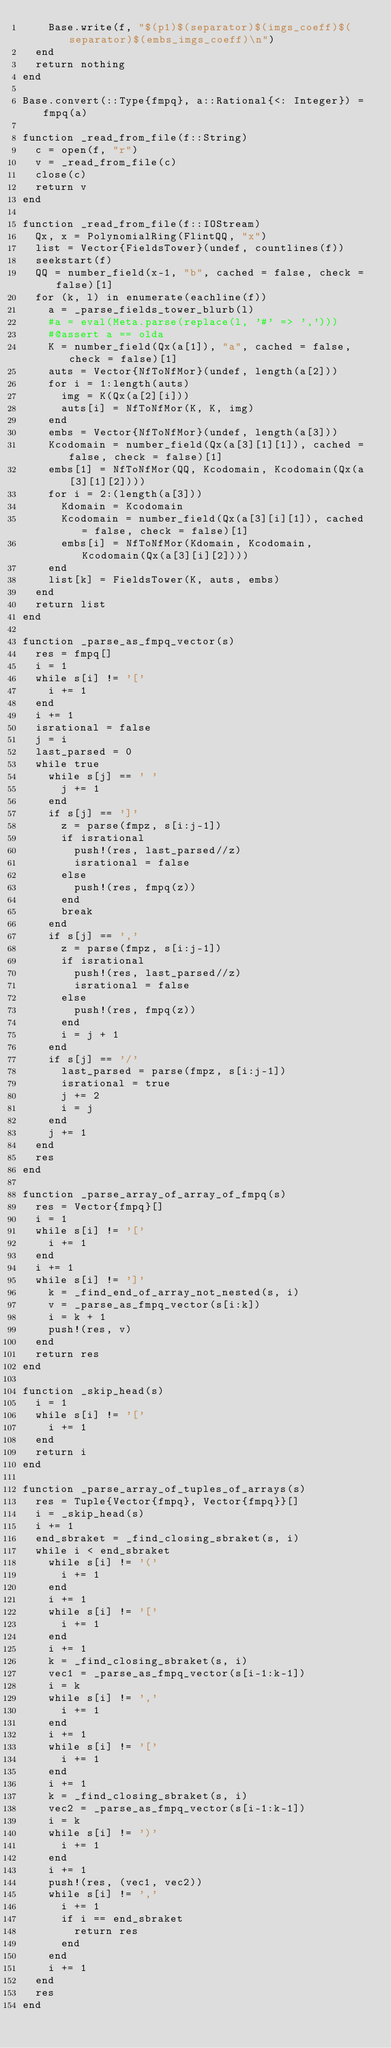Convert code to text. <code><loc_0><loc_0><loc_500><loc_500><_Julia_>    Base.write(f, "$(p1)$(separator)$(imgs_coeff)$(separator)$(embs_imgs_coeff)\n")
  end
  return nothing
end

Base.convert(::Type{fmpq}, a::Rational{<: Integer}) = fmpq(a)

function _read_from_file(f::String)
  c = open(f, "r")
  v = _read_from_file(c)
  close(c)
  return v
end

function _read_from_file(f::IOStream)
  Qx, x = PolynomialRing(FlintQQ, "x")
  list = Vector{FieldsTower}(undef, countlines(f))
  seekstart(f)
  QQ = number_field(x-1, "b", cached = false, check = false)[1]
  for (k, l) in enumerate(eachline(f))
    a = _parse_fields_tower_blurb(l)
    #a = eval(Meta.parse(replace(l, '#' => ',')))
    #@assert a == olda
    K = number_field(Qx(a[1]), "a", cached = false, check = false)[1]
    auts = Vector{NfToNfMor}(undef, length(a[2]))
    for i = 1:length(auts)
      img = K(Qx(a[2][i]))
      auts[i] = NfToNfMor(K, K, img)
    end
    embs = Vector{NfToNfMor}(undef, length(a[3]))
    Kcodomain = number_field(Qx(a[3][1][1]), cached = false, check = false)[1]
    embs[1] = NfToNfMor(QQ, Kcodomain, Kcodomain(Qx(a[3][1][2])))
    for i = 2:(length(a[3]))
      Kdomain = Kcodomain
      Kcodomain = number_field(Qx(a[3][i][1]), cached = false, check = false)[1]
      embs[i] = NfToNfMor(Kdomain, Kcodomain, Kcodomain(Qx(a[3][i][2])))
    end
    list[k] = FieldsTower(K, auts, embs)
  end
  return list
end

function _parse_as_fmpq_vector(s)
  res = fmpq[]
  i = 1
  while s[i] != '['
    i += 1
  end
  i += 1
  isrational = false
  j = i
  last_parsed = 0
  while true
    while s[j] == ' '
      j += 1
    end
    if s[j] == ']'
      z = parse(fmpz, s[i:j-1])
      if isrational
        push!(res, last_parsed//z)
        isrational = false
      else
        push!(res, fmpq(z))
      end
      break
    end
    if s[j] == ','
      z = parse(fmpz, s[i:j-1])
      if isrational
        push!(res, last_parsed//z)
        isrational = false
      else
        push!(res, fmpq(z))
      end
      i = j + 1
    end
    if s[j] == '/'
      last_parsed = parse(fmpz, s[i:j-1])
      isrational = true
      j += 2
      i = j
    end
    j += 1
  end
  res
end

function _parse_array_of_array_of_fmpq(s)
  res = Vector{fmpq}[]
  i = 1
  while s[i] != '['
    i += 1
  end
  i += 1
  while s[i] != ']'
    k = _find_end_of_array_not_nested(s, i)
    v = _parse_as_fmpq_vector(s[i:k])
    i = k + 1
    push!(res, v)
  end
  return res
end

function _skip_head(s)
  i = 1
  while s[i] != '['
    i += 1
  end
  return i
end

function _parse_array_of_tuples_of_arrays(s)
  res = Tuple{Vector{fmpq}, Vector{fmpq}}[]
  i = _skip_head(s)
  i += 1
  end_sbraket = _find_closing_sbraket(s, i)
  while i < end_sbraket
    while s[i] != '('
      i += 1
    end
    i += 1
    while s[i] != '['
      i += 1
    end
    i += 1
    k = _find_closing_sbraket(s, i)
    vec1 = _parse_as_fmpq_vector(s[i-1:k-1])
    i = k 
    while s[i] != ','
      i += 1
    end
    i += 1
    while s[i] != '['
      i += 1
    end
    i += 1
    k = _find_closing_sbraket(s, i)
    vec2 = _parse_as_fmpq_vector(s[i-1:k-1])
    i = k
    while s[i] != ')'
      i += 1
    end
    i += 1
    push!(res, (vec1, vec2))
    while s[i] != ','
      i += 1
      if i == end_sbraket
        return res
      end
    end
    i += 1
  end
  res
end
</code> 